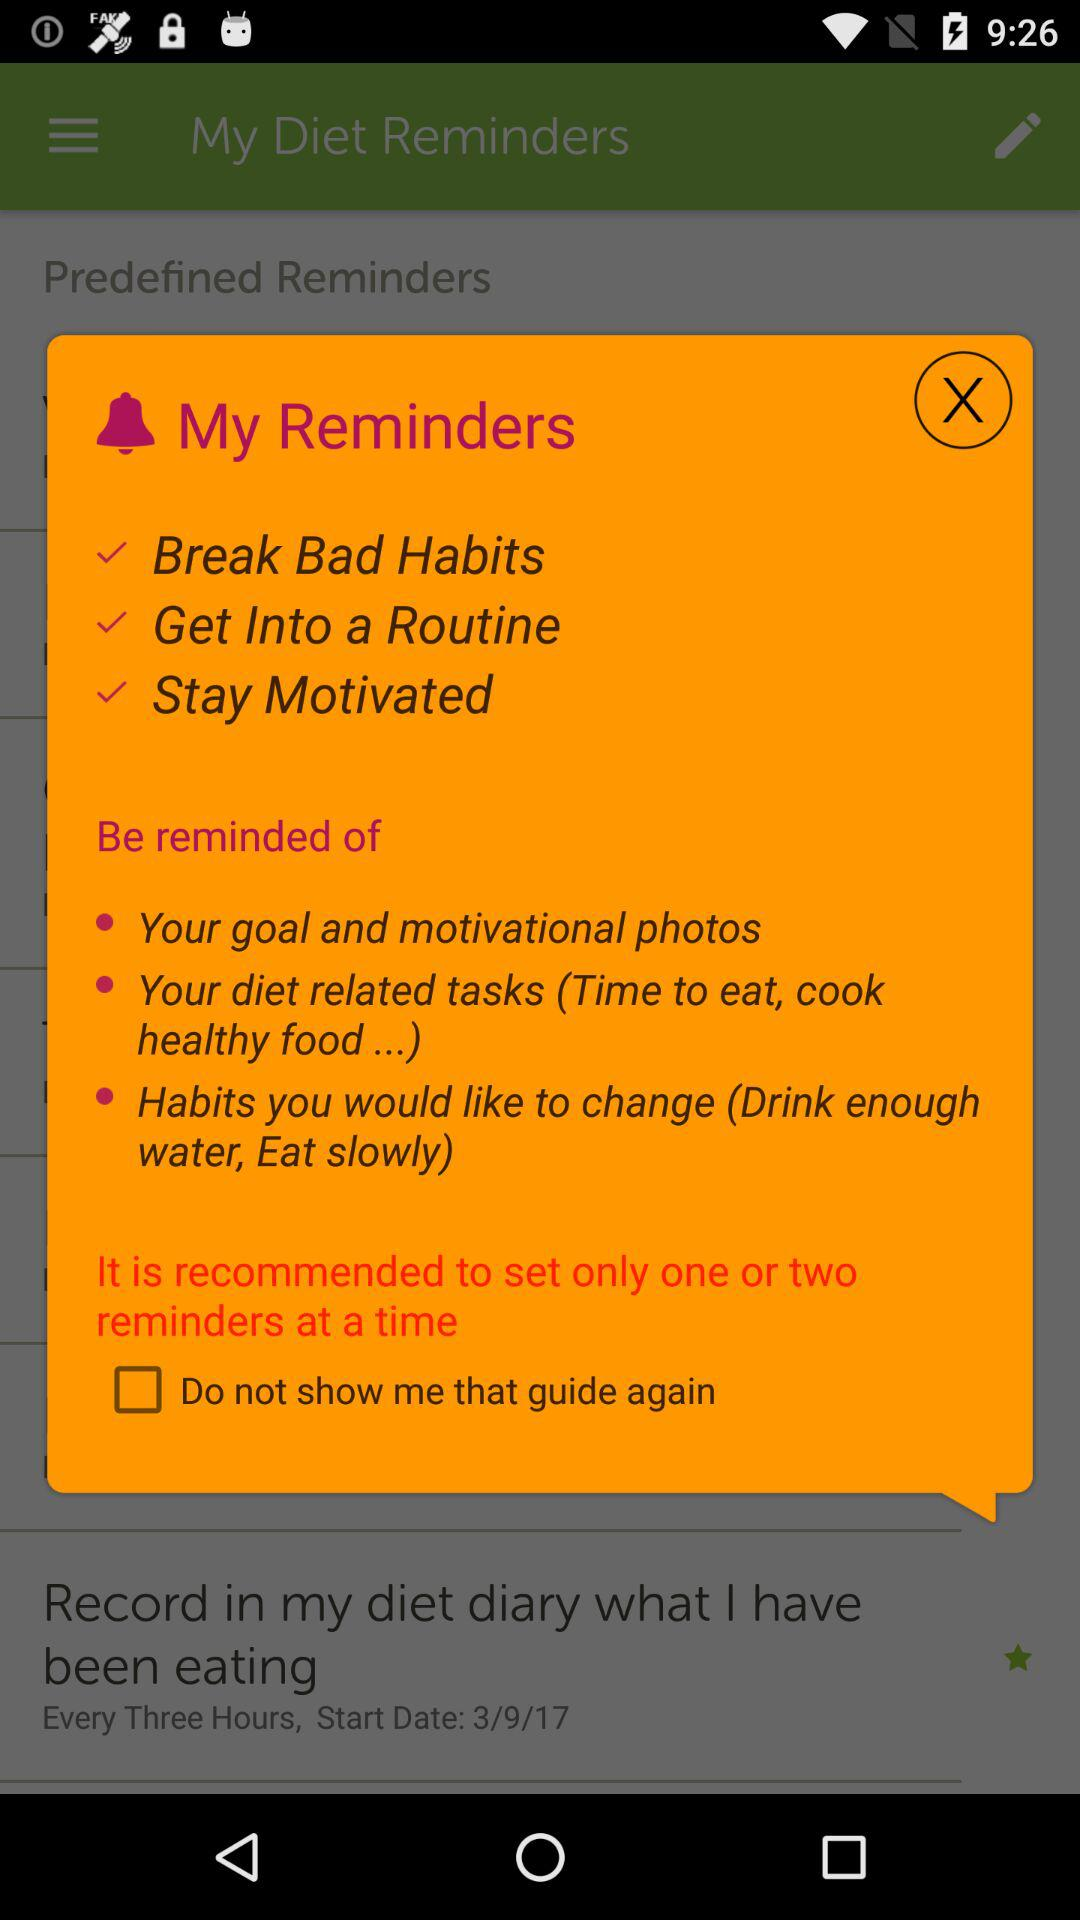How many days has the user been using diet-related reminders?
When the provided information is insufficient, respond with <no answer>. <no answer> 